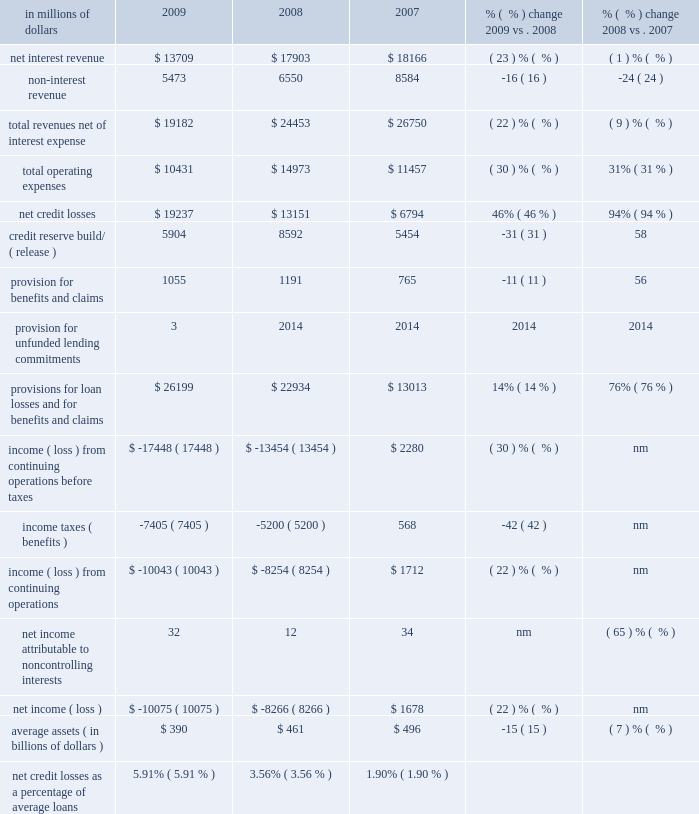Local consumer lending local consumer lending ( lcl ) , which constituted approximately 65% ( 65 % ) of citi holdings by assets as of december 31 , 2009 , includes a portion of citigroup 2019s north american mortgage business , retail partner cards , western european cards and retail banking , citifinancial north america , primerica , student loan corporation and other local consumer finance businesses globally .
At december 31 , 2009 , lcl had $ 358 billion of assets ( $ 317 billion in north america ) .
About one-half of the assets in lcl as of december 31 , 2009 consisted of u.s .
Mortgages in the company 2019s citimortgage and citifinancial operations .
The north american assets consist of residential mortgage loans , retail partner card loans , student loans , personal loans , auto loans , commercial real estate , and other consumer loans and assets .
In millions of dollars 2009 2008 2007 % (  % ) change 2009 vs .
2008 % (  % ) change 2008 vs .
2007 .
Nm not meaningful 2009 vs .
2008 revenues , net of interest expense decreased 22% ( 22 % ) versus the prior year , mostly due to lower net interest revenue .
Net interest revenue was 23% ( 23 % ) lower than the prior year , primarily due to lower balances , de-risking of the portfolio , and spread compression .
Net interest revenue as a percentage of average loans decreased 63 basis points from the prior year , primarily due to the impact of higher delinquencies , interest write-offs , loan modification programs , higher fdic charges and card act implementation ( in the latter part of 2009 ) , partially offset by retail partner cards pricing actions .
Lcl results will continue to be impacted by the card act .
Citi currently estimates that the net impact on lcl revenues for 2010 could be a reduction of approximately $ 50 to $ 150 million .
See also 201cnorth america regional consumer banking 201d and 201cmanaging global risk 2014credit risk 201d for additional information on the impact of the card act to citi 2019s credit card businesses .
Average loans decreased 12% ( 12 % ) , with north america down 11% ( 11 % ) and international down 19% ( 19 % ) .
Non-interest revenue decreased $ 1.1 billion mostly driven by the impact of higher credit losses flowing through the securitization trusts .
Operating expenses declined 30% ( 30 % ) from the prior year , due to lower volumes and reductions from expense re-engineering actions , and the impact of goodwill write-offs of $ 3.0 billion in the fourth quarter of 2008 , partially offset by higher other real estate owned and collection costs .
Provisions for loan losses and for benefits and claims increased 14% ( 14 % ) versus the prior year reflecting an increase in net credit losses of $ 6.1 billion , partially offset by lower reserve builds of $ 2.7 billion .
Higher net credit losses were primarily driven by higher losses of $ 3.6 billion in residential real estate lending , $ 1.0 billion in retail partner cards , and $ 0.7 billion in international .
Assets decreased $ 58 billion versus the prior year , primarily driven by lower originations , wind-down of specific businesses , asset sales , divestitures , write-offs and higher loan loss reserve balances .
Key divestitures in 2009 included the fi credit card business , italy consumer finance , diners europe , portugal cards , norway consumer , and diners club north america .
2008 vs .
2007 revenues , net of interest expense decreased 9% ( 9 % ) versus the prior year , mostly due to lower non-interest revenue .
Net interest revenue declined 1% ( 1 % ) versus the prior year .
Average loans increased 3% ( 3 % ) ; however , revenues declined , driven by lower balances , de-risking of the portfolio , and spread compression .
Non-interest revenue decreased $ 2 billion , primarily due to the impact of securitization in retail partners cards and the mark-to-market on the mortgage servicing rights asset and related hedge in real estate lending .
Operating expenses increased 31% ( 31 % ) , driven by the impact of goodwill write-offs of $ 3.0 billion in the fourth quarter of 2008 and restructuring costs .
Excluding one-time expenses , expenses were slightly higher due to increased volumes. .
What percent of total revenues net of interest expense was non-interest revenue in 2008? 
Computations: (6550 / 24453)
Answer: 0.26786. 